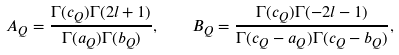<formula> <loc_0><loc_0><loc_500><loc_500>A _ { Q } = \frac { \Gamma ( c _ { Q } ) \Gamma ( 2 l + 1 ) } { \Gamma ( a _ { Q } ) \Gamma ( b _ { Q } ) } , \quad B _ { Q } = \frac { \Gamma ( c _ { Q } ) \Gamma ( - 2 l - 1 ) } { \Gamma ( c _ { Q } - a _ { Q } ) \Gamma ( c _ { Q } - b _ { Q } ) } ,</formula> 